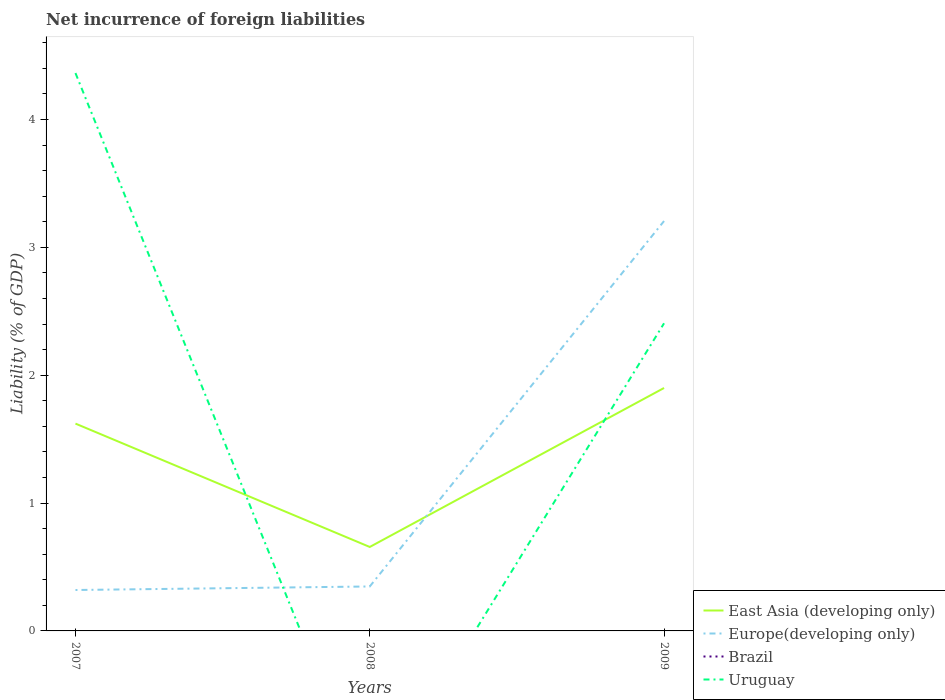Does the line corresponding to Brazil intersect with the line corresponding to East Asia (developing only)?
Make the answer very short. No. Is the number of lines equal to the number of legend labels?
Offer a terse response. No. Across all years, what is the maximum net incurrence of foreign liabilities in Europe(developing only)?
Offer a very short reply. 0.32. What is the total net incurrence of foreign liabilities in Uruguay in the graph?
Provide a succinct answer. 1.96. What is the difference between the highest and the second highest net incurrence of foreign liabilities in Europe(developing only)?
Provide a short and direct response. 2.89. Is the net incurrence of foreign liabilities in Europe(developing only) strictly greater than the net incurrence of foreign liabilities in East Asia (developing only) over the years?
Give a very brief answer. No. How many lines are there?
Make the answer very short. 3. How many years are there in the graph?
Your answer should be very brief. 3. What is the difference between two consecutive major ticks on the Y-axis?
Offer a very short reply. 1. Are the values on the major ticks of Y-axis written in scientific E-notation?
Keep it short and to the point. No. Does the graph contain grids?
Give a very brief answer. No. What is the title of the graph?
Offer a terse response. Net incurrence of foreign liabilities. What is the label or title of the X-axis?
Offer a very short reply. Years. What is the label or title of the Y-axis?
Make the answer very short. Liability (% of GDP). What is the Liability (% of GDP) of East Asia (developing only) in 2007?
Your response must be concise. 1.62. What is the Liability (% of GDP) in Europe(developing only) in 2007?
Your answer should be very brief. 0.32. What is the Liability (% of GDP) of Brazil in 2007?
Provide a succinct answer. 0. What is the Liability (% of GDP) of Uruguay in 2007?
Make the answer very short. 4.36. What is the Liability (% of GDP) of East Asia (developing only) in 2008?
Ensure brevity in your answer.  0.66. What is the Liability (% of GDP) in Europe(developing only) in 2008?
Your answer should be compact. 0.35. What is the Liability (% of GDP) of East Asia (developing only) in 2009?
Give a very brief answer. 1.9. What is the Liability (% of GDP) of Europe(developing only) in 2009?
Your response must be concise. 3.21. What is the Liability (% of GDP) of Brazil in 2009?
Keep it short and to the point. 0. What is the Liability (% of GDP) of Uruguay in 2009?
Ensure brevity in your answer.  2.41. Across all years, what is the maximum Liability (% of GDP) of East Asia (developing only)?
Provide a short and direct response. 1.9. Across all years, what is the maximum Liability (% of GDP) in Europe(developing only)?
Keep it short and to the point. 3.21. Across all years, what is the maximum Liability (% of GDP) in Uruguay?
Offer a very short reply. 4.36. Across all years, what is the minimum Liability (% of GDP) of East Asia (developing only)?
Provide a succinct answer. 0.66. Across all years, what is the minimum Liability (% of GDP) in Europe(developing only)?
Keep it short and to the point. 0.32. What is the total Liability (% of GDP) of East Asia (developing only) in the graph?
Give a very brief answer. 4.18. What is the total Liability (% of GDP) of Europe(developing only) in the graph?
Ensure brevity in your answer.  3.87. What is the total Liability (% of GDP) in Brazil in the graph?
Your response must be concise. 0. What is the total Liability (% of GDP) in Uruguay in the graph?
Give a very brief answer. 6.77. What is the difference between the Liability (% of GDP) in East Asia (developing only) in 2007 and that in 2008?
Give a very brief answer. 0.96. What is the difference between the Liability (% of GDP) in Europe(developing only) in 2007 and that in 2008?
Ensure brevity in your answer.  -0.03. What is the difference between the Liability (% of GDP) in East Asia (developing only) in 2007 and that in 2009?
Your response must be concise. -0.28. What is the difference between the Liability (% of GDP) of Europe(developing only) in 2007 and that in 2009?
Keep it short and to the point. -2.89. What is the difference between the Liability (% of GDP) in Uruguay in 2007 and that in 2009?
Make the answer very short. 1.96. What is the difference between the Liability (% of GDP) of East Asia (developing only) in 2008 and that in 2009?
Your answer should be compact. -1.24. What is the difference between the Liability (% of GDP) in Europe(developing only) in 2008 and that in 2009?
Keep it short and to the point. -2.86. What is the difference between the Liability (% of GDP) in East Asia (developing only) in 2007 and the Liability (% of GDP) in Europe(developing only) in 2008?
Offer a very short reply. 1.27. What is the difference between the Liability (% of GDP) in East Asia (developing only) in 2007 and the Liability (% of GDP) in Europe(developing only) in 2009?
Offer a terse response. -1.58. What is the difference between the Liability (% of GDP) in East Asia (developing only) in 2007 and the Liability (% of GDP) in Uruguay in 2009?
Make the answer very short. -0.78. What is the difference between the Liability (% of GDP) in Europe(developing only) in 2007 and the Liability (% of GDP) in Uruguay in 2009?
Provide a succinct answer. -2.09. What is the difference between the Liability (% of GDP) in East Asia (developing only) in 2008 and the Liability (% of GDP) in Europe(developing only) in 2009?
Make the answer very short. -2.55. What is the difference between the Liability (% of GDP) of East Asia (developing only) in 2008 and the Liability (% of GDP) of Uruguay in 2009?
Offer a terse response. -1.75. What is the difference between the Liability (% of GDP) in Europe(developing only) in 2008 and the Liability (% of GDP) in Uruguay in 2009?
Your answer should be very brief. -2.06. What is the average Liability (% of GDP) of East Asia (developing only) per year?
Offer a terse response. 1.39. What is the average Liability (% of GDP) of Europe(developing only) per year?
Provide a short and direct response. 1.29. What is the average Liability (% of GDP) in Brazil per year?
Offer a very short reply. 0. What is the average Liability (% of GDP) in Uruguay per year?
Keep it short and to the point. 2.26. In the year 2007, what is the difference between the Liability (% of GDP) in East Asia (developing only) and Liability (% of GDP) in Europe(developing only)?
Offer a very short reply. 1.3. In the year 2007, what is the difference between the Liability (% of GDP) in East Asia (developing only) and Liability (% of GDP) in Uruguay?
Give a very brief answer. -2.74. In the year 2007, what is the difference between the Liability (% of GDP) of Europe(developing only) and Liability (% of GDP) of Uruguay?
Provide a short and direct response. -4.04. In the year 2008, what is the difference between the Liability (% of GDP) in East Asia (developing only) and Liability (% of GDP) in Europe(developing only)?
Make the answer very short. 0.31. In the year 2009, what is the difference between the Liability (% of GDP) in East Asia (developing only) and Liability (% of GDP) in Europe(developing only)?
Your answer should be compact. -1.31. In the year 2009, what is the difference between the Liability (% of GDP) in East Asia (developing only) and Liability (% of GDP) in Uruguay?
Keep it short and to the point. -0.51. In the year 2009, what is the difference between the Liability (% of GDP) in Europe(developing only) and Liability (% of GDP) in Uruguay?
Provide a short and direct response. 0.8. What is the ratio of the Liability (% of GDP) of East Asia (developing only) in 2007 to that in 2008?
Make the answer very short. 2.47. What is the ratio of the Liability (% of GDP) of Europe(developing only) in 2007 to that in 2008?
Ensure brevity in your answer.  0.92. What is the ratio of the Liability (% of GDP) in East Asia (developing only) in 2007 to that in 2009?
Provide a succinct answer. 0.85. What is the ratio of the Liability (% of GDP) in Europe(developing only) in 2007 to that in 2009?
Your answer should be very brief. 0.1. What is the ratio of the Liability (% of GDP) in Uruguay in 2007 to that in 2009?
Make the answer very short. 1.81. What is the ratio of the Liability (% of GDP) of East Asia (developing only) in 2008 to that in 2009?
Ensure brevity in your answer.  0.35. What is the ratio of the Liability (% of GDP) in Europe(developing only) in 2008 to that in 2009?
Offer a terse response. 0.11. What is the difference between the highest and the second highest Liability (% of GDP) in East Asia (developing only)?
Provide a succinct answer. 0.28. What is the difference between the highest and the second highest Liability (% of GDP) in Europe(developing only)?
Make the answer very short. 2.86. What is the difference between the highest and the lowest Liability (% of GDP) of East Asia (developing only)?
Make the answer very short. 1.24. What is the difference between the highest and the lowest Liability (% of GDP) in Europe(developing only)?
Your response must be concise. 2.89. What is the difference between the highest and the lowest Liability (% of GDP) of Uruguay?
Your response must be concise. 4.36. 